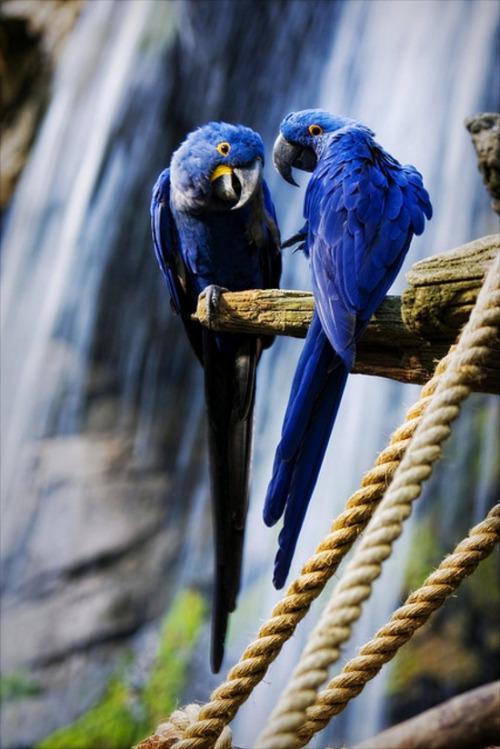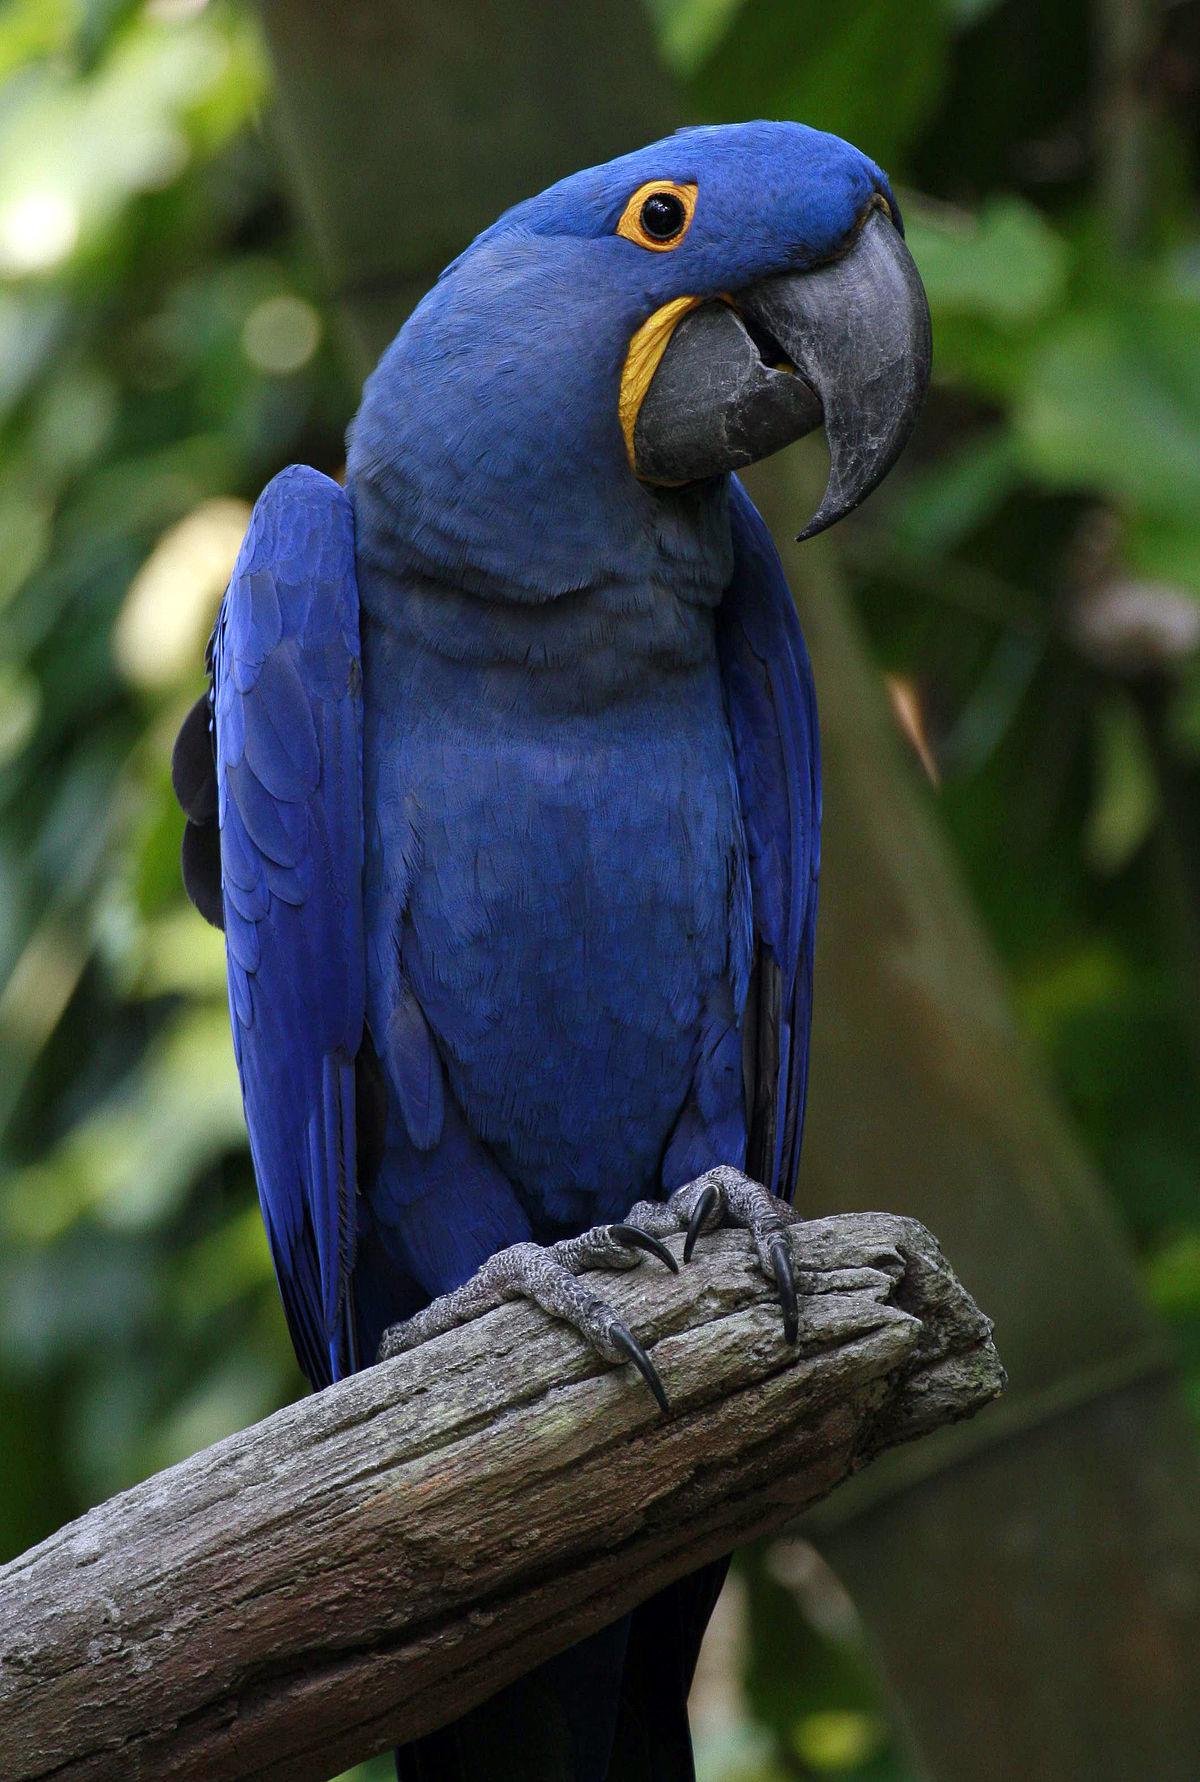The first image is the image on the left, the second image is the image on the right. Examine the images to the left and right. Is the description "There are three blue parrots." accurate? Answer yes or no. Yes. The first image is the image on the left, the second image is the image on the right. For the images shown, is this caption "One image contains twice as many blue parrots as the other image, and an image shows two birds perched on something made of wood." true? Answer yes or no. Yes. 